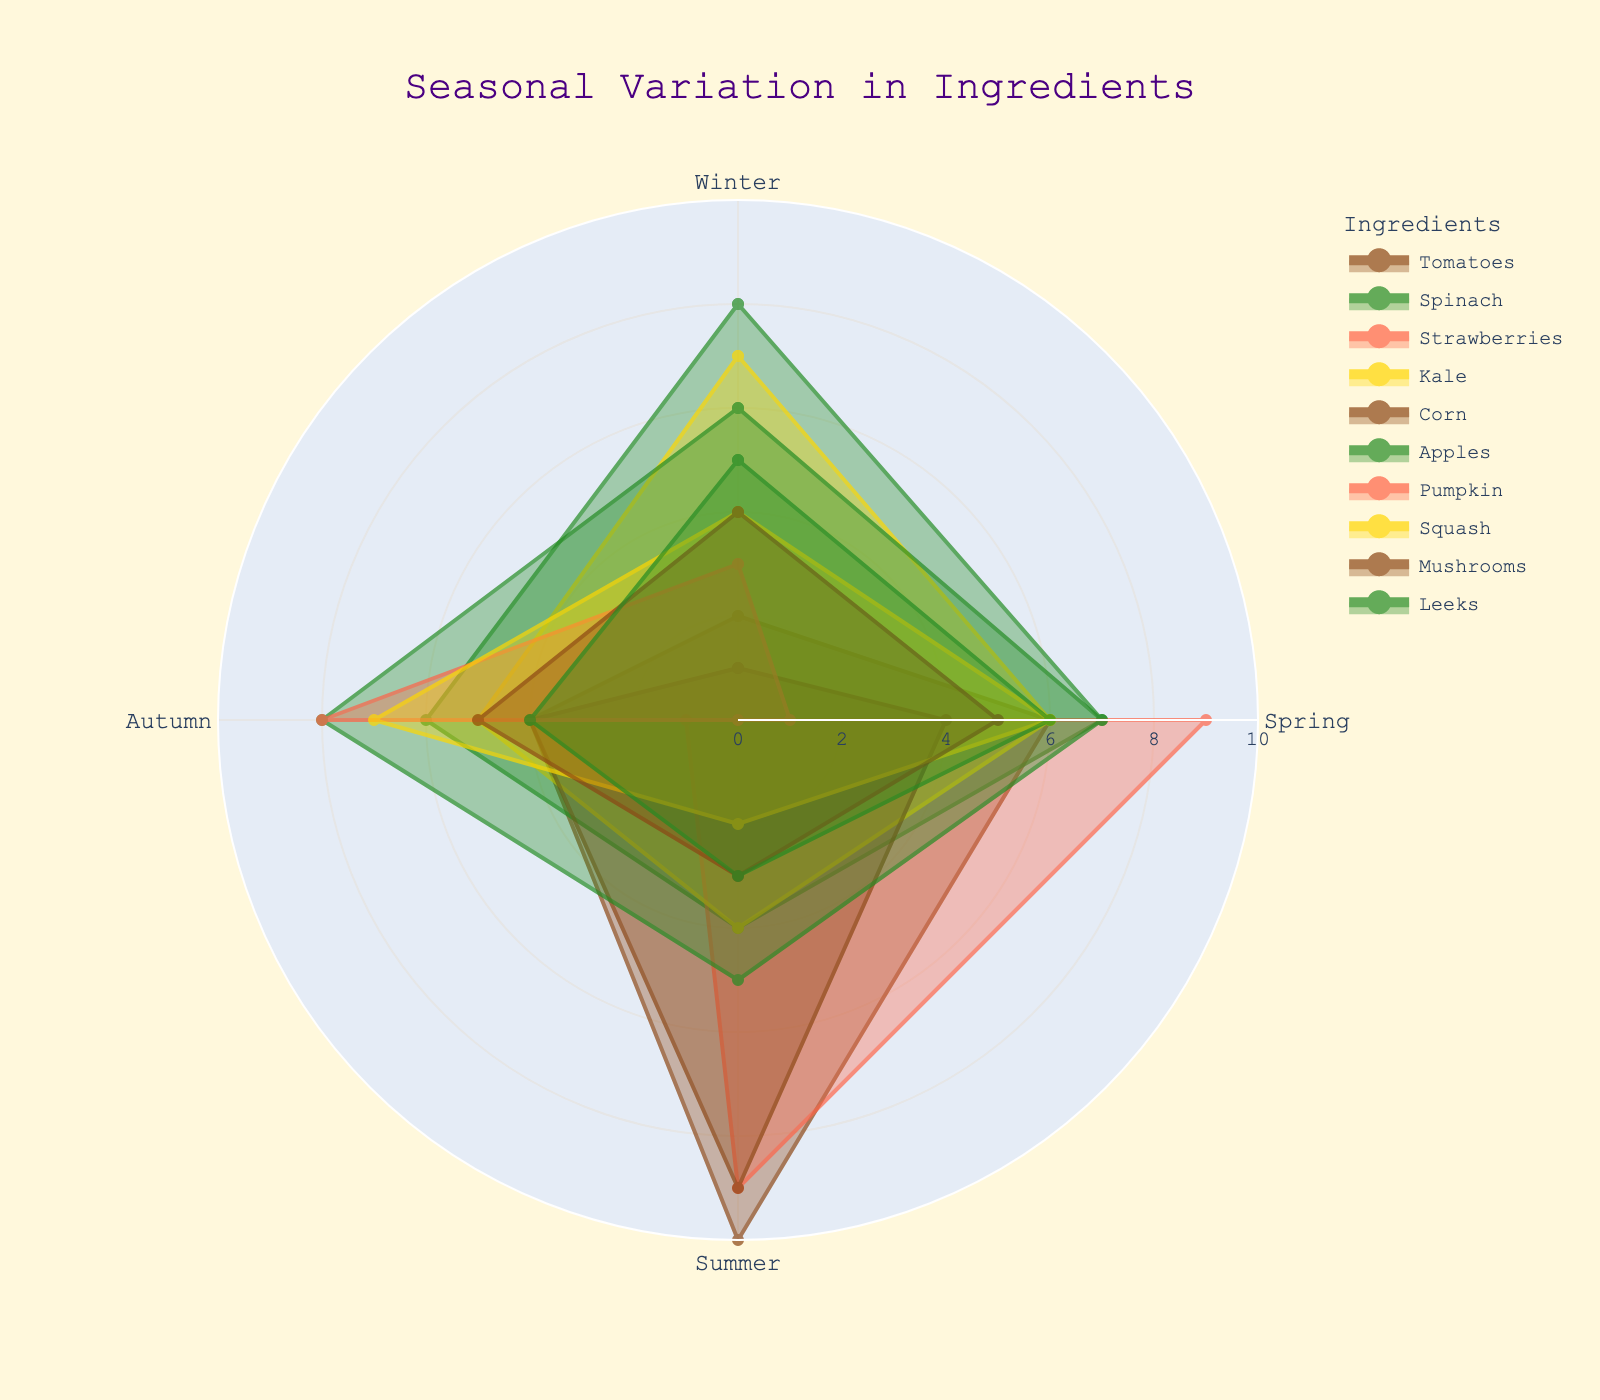What does the title of the radar chart say? The title is prominently displayed at the top center of the chart, and reading it directly gives us the title information.
Answer: Seasonal Variation in Ingredients Which ingredient has the highest value in Summer? By examining the Summer segment of each ingredient's plot, it's clear that Tomatoes and Strawberries both have the highest value, which is 10.
Answer: Tomatoes and Strawberries How many ingredients peak in Winter? Checking the Winter segment for each ingredient, we see that Spinach (8) and Kale (7) have their peak values in Winter.
Answer: 2 Which ingredient is used the least in Autumn? Looking at the Autumn values for each ingredient, Strawberries have the lowest value, which is 1.
Answer: Strawberries What is the average availability of Spinach throughout the seasons? Summing the values of Spinach (8 + 7 + 4 + 6) gives 25. Dividing by the number of seasons (4) gives 25/4 = 6.25.
Answer: 6.25 Which two ingredients have similar usage patterns across all seasons? Comparing all segments, we see that Kale and Mushrooms have very close values in each season, indicating similar usage patterns.
Answer: Kale and Mushrooms How many ingredients have a usage value of 6 in Spring? Checking the Spring segment for each ingredient, we find that Tomatoes, Apples, Squash, and Leeks all have a value of 6.
Answer: 4 Is the usage of Kale higher in Spring or Autumn? Comparing the values in Spring (6) and Autumn (5) for Kale, we see it is higher in Spring.
Answer: Spring What is the difference between the highest and lowest value of Tomatoes? The highest value for Tomatoes is 10 (Summer) and the lowest is 2 (Winter). The difference is 10 - 2 = 8.
Answer: 8 Does any ingredient have zero availability in multiple seasons? Observing the plot, Strawberries have a value of 0 in Winter, and Pumpkin has a value of 0 in Summer. So, only one ingredient (Strawberries) has zero availability in more than one season.
Answer: No 